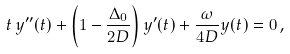<formula> <loc_0><loc_0><loc_500><loc_500>t \, y ^ { \prime \prime } ( t ) + \left ( 1 - \frac { \Delta _ { 0 } } { 2 D } \right ) y ^ { \prime } ( t ) + \frac { \omega } { 4 D } y ( t ) = 0 \, ,</formula> 